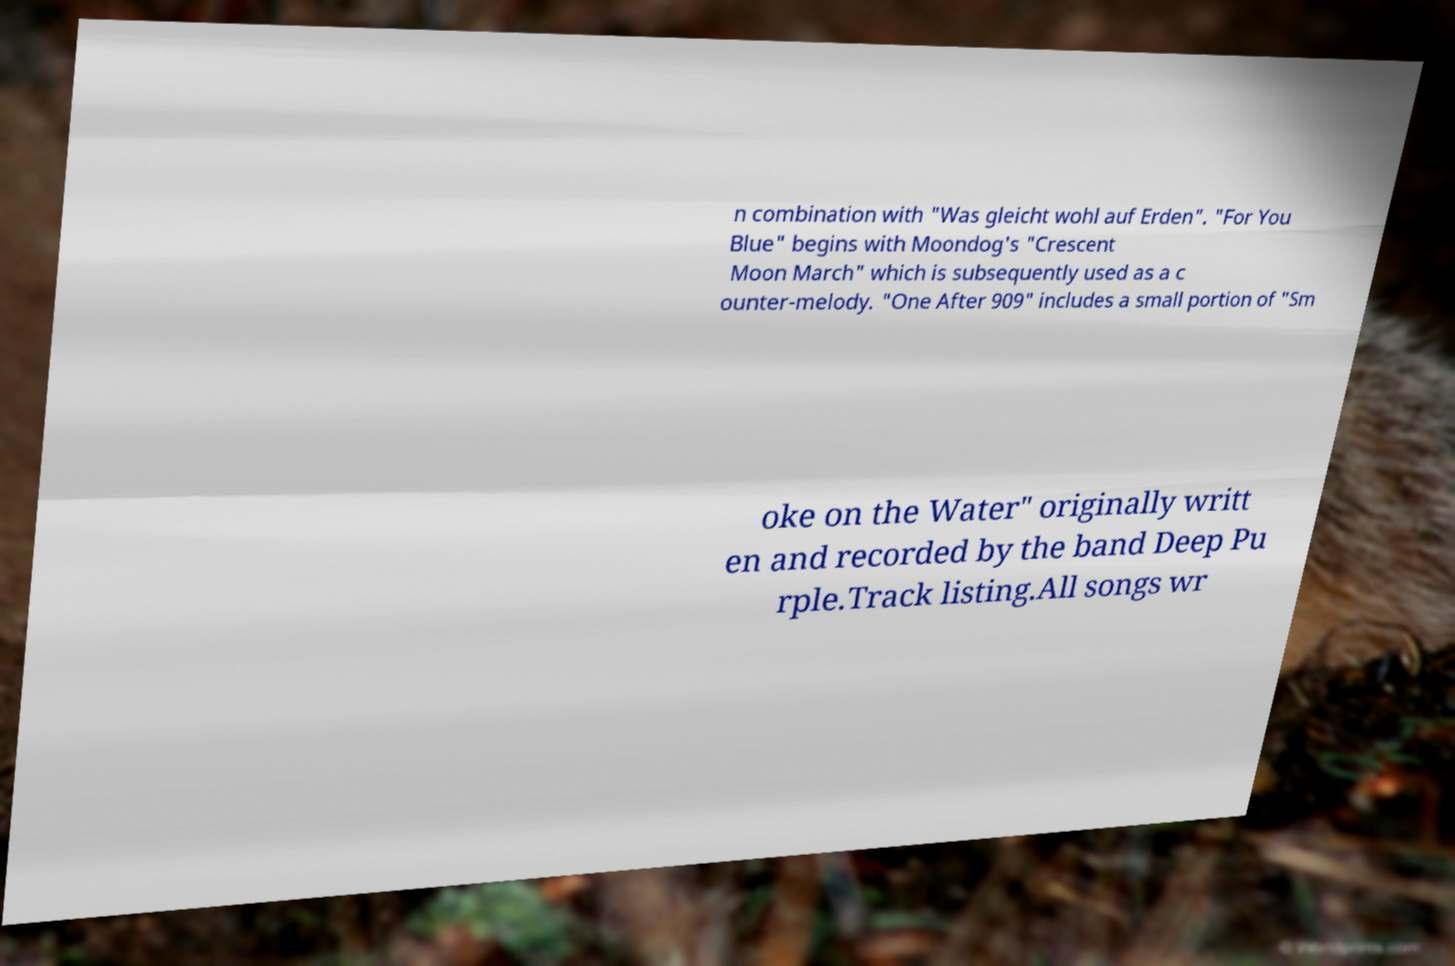Could you extract and type out the text from this image? n combination with "Was gleicht wohl auf Erden". "For You Blue" begins with Moondog's "Crescent Moon March" which is subsequently used as a c ounter-melody. "One After 909" includes a small portion of "Sm oke on the Water" originally writt en and recorded by the band Deep Pu rple.Track listing.All songs wr 